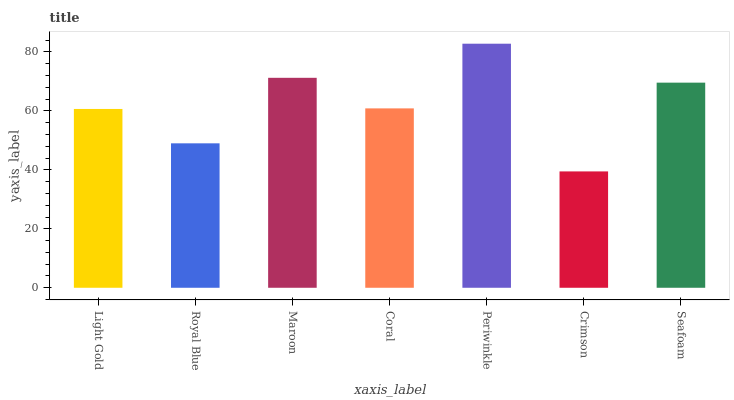Is Crimson the minimum?
Answer yes or no. Yes. Is Periwinkle the maximum?
Answer yes or no. Yes. Is Royal Blue the minimum?
Answer yes or no. No. Is Royal Blue the maximum?
Answer yes or no. No. Is Light Gold greater than Royal Blue?
Answer yes or no. Yes. Is Royal Blue less than Light Gold?
Answer yes or no. Yes. Is Royal Blue greater than Light Gold?
Answer yes or no. No. Is Light Gold less than Royal Blue?
Answer yes or no. No. Is Coral the high median?
Answer yes or no. Yes. Is Coral the low median?
Answer yes or no. Yes. Is Royal Blue the high median?
Answer yes or no. No. Is Maroon the low median?
Answer yes or no. No. 